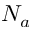<formula> <loc_0><loc_0><loc_500><loc_500>N _ { a }</formula> 